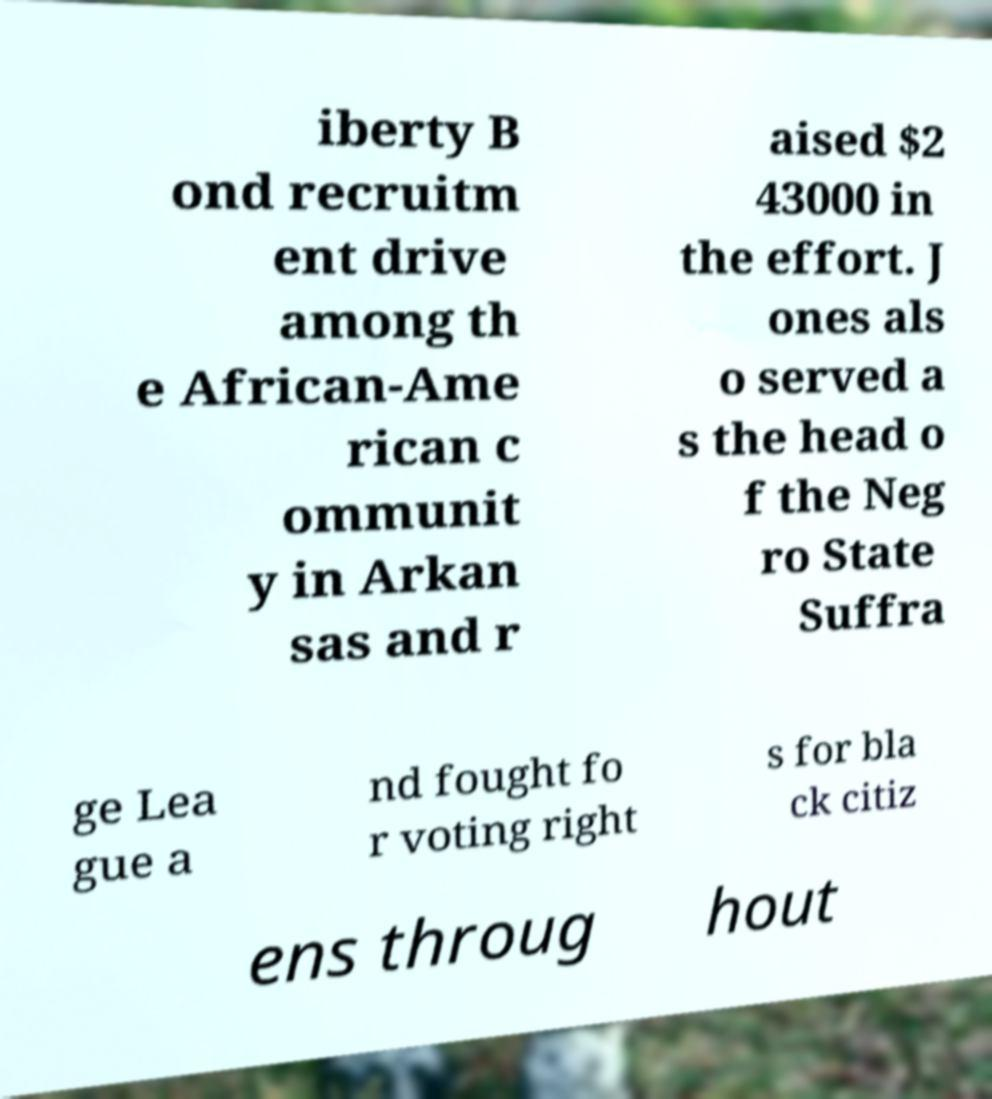For documentation purposes, I need the text within this image transcribed. Could you provide that? iberty B ond recruitm ent drive among th e African-Ame rican c ommunit y in Arkan sas and r aised $2 43000 in the effort. J ones als o served a s the head o f the Neg ro State Suffra ge Lea gue a nd fought fo r voting right s for bla ck citiz ens throug hout 